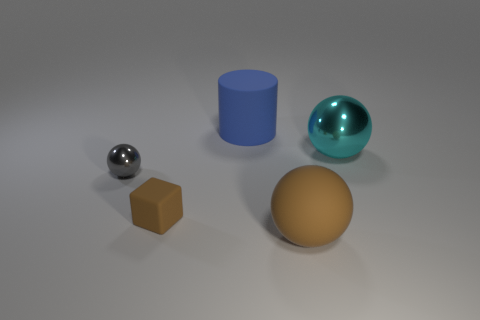How many other objects are the same shape as the cyan shiny object?
Give a very brief answer. 2. What is the color of the rubber sphere that is the same size as the cyan metal sphere?
Your response must be concise. Brown. How many spheres are cyan things or small metallic things?
Your answer should be very brief. 2. How many blue objects are there?
Your answer should be compact. 1. Does the large brown thing have the same shape as the shiny object that is right of the small gray metallic sphere?
Give a very brief answer. Yes. There is a rubber sphere that is the same color as the tiny block; what is its size?
Keep it short and to the point. Large. What number of things are either small blue cylinders or big blue matte cylinders?
Ensure brevity in your answer.  1. What shape is the big rubber object that is in front of the big matte thing behind the cyan ball?
Your answer should be compact. Sphere. Does the shiny thing left of the small brown cube have the same shape as the cyan shiny object?
Make the answer very short. Yes. What size is the brown block that is the same material as the cylinder?
Your answer should be very brief. Small. 